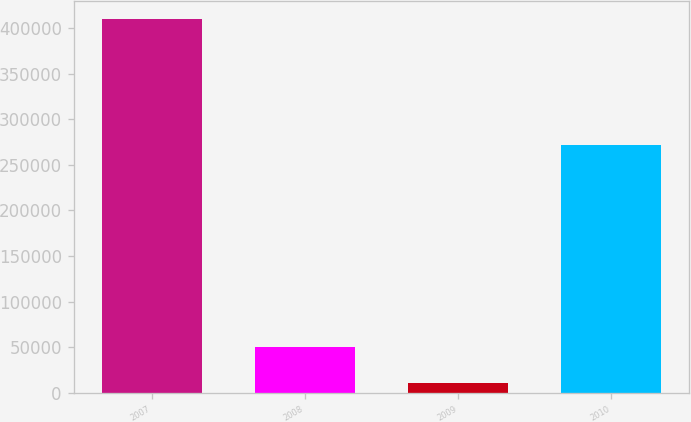<chart> <loc_0><loc_0><loc_500><loc_500><bar_chart><fcel>2007<fcel>2008<fcel>2009<fcel>2010<nl><fcel>409362<fcel>50668.8<fcel>10814<fcel>271595<nl></chart> 